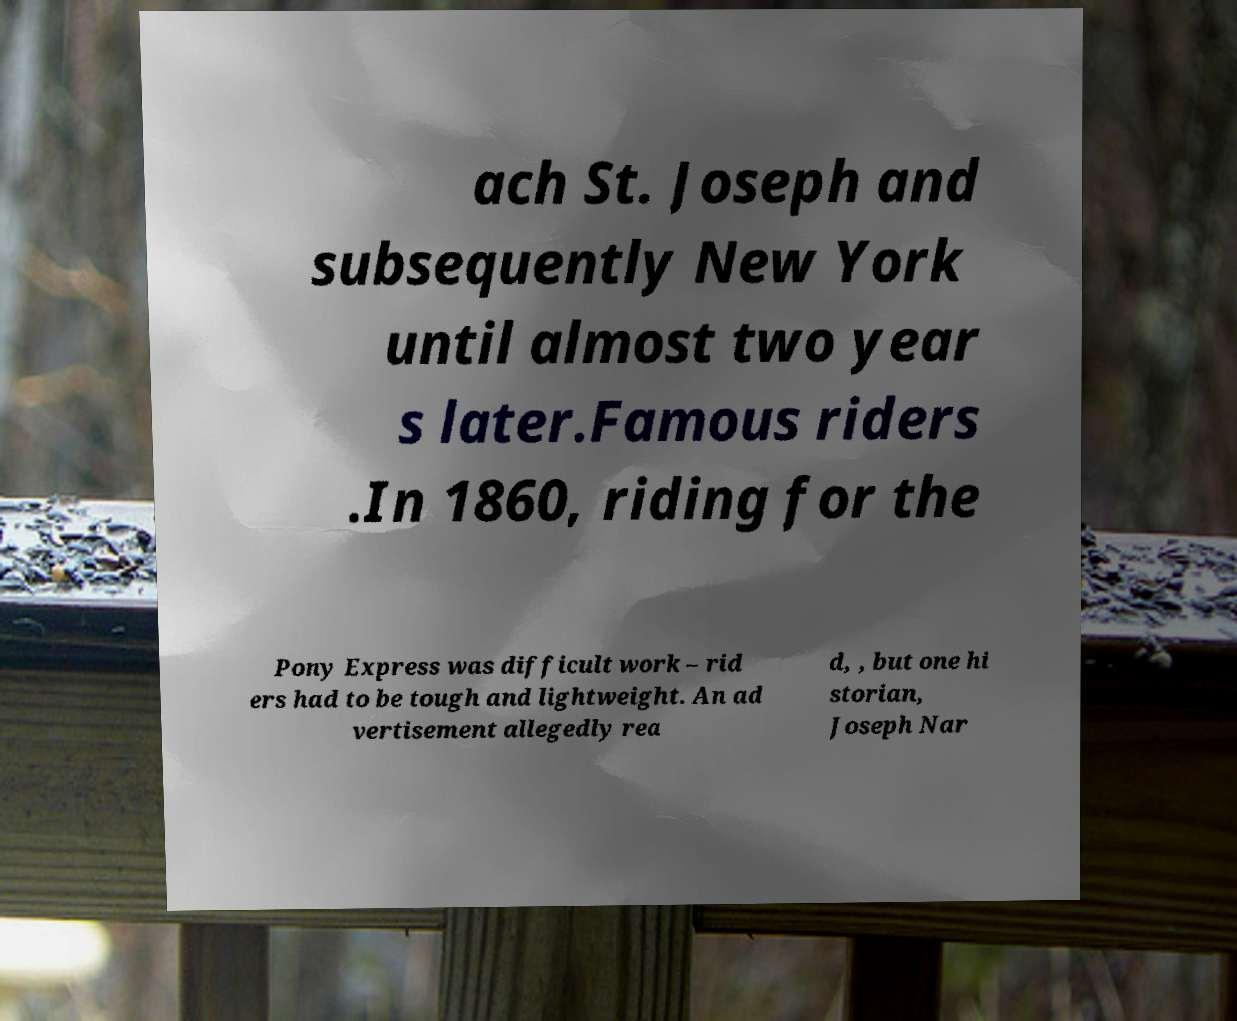Please identify and transcribe the text found in this image. ach St. Joseph and subsequently New York until almost two year s later.Famous riders .In 1860, riding for the Pony Express was difficult work – rid ers had to be tough and lightweight. An ad vertisement allegedly rea d, , but one hi storian, Joseph Nar 